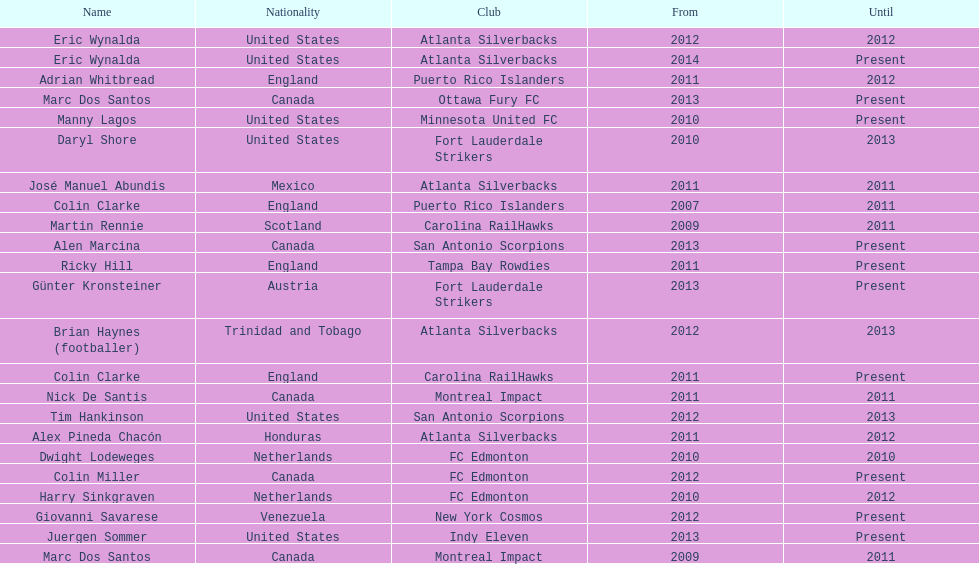How long did colin clarke coach the puerto rico islanders? 4 years. Write the full table. {'header': ['Name', 'Nationality', 'Club', 'From', 'Until'], 'rows': [['Eric Wynalda', 'United States', 'Atlanta Silverbacks', '2012', '2012'], ['Eric Wynalda', 'United States', 'Atlanta Silverbacks', '2014', 'Present'], ['Adrian Whitbread', 'England', 'Puerto Rico Islanders', '2011', '2012'], ['Marc Dos Santos', 'Canada', 'Ottawa Fury FC', '2013', 'Present'], ['Manny Lagos', 'United States', 'Minnesota United FC', '2010', 'Present'], ['Daryl Shore', 'United States', 'Fort Lauderdale Strikers', '2010', '2013'], ['José Manuel Abundis', 'Mexico', 'Atlanta Silverbacks', '2011', '2011'], ['Colin Clarke', 'England', 'Puerto Rico Islanders', '2007', '2011'], ['Martin Rennie', 'Scotland', 'Carolina RailHawks', '2009', '2011'], ['Alen Marcina', 'Canada', 'San Antonio Scorpions', '2013', 'Present'], ['Ricky Hill', 'England', 'Tampa Bay Rowdies', '2011', 'Present'], ['Günter Kronsteiner', 'Austria', 'Fort Lauderdale Strikers', '2013', 'Present'], ['Brian Haynes (footballer)', 'Trinidad and Tobago', 'Atlanta Silverbacks', '2012', '2013'], ['Colin Clarke', 'England', 'Carolina RailHawks', '2011', 'Present'], ['Nick De Santis', 'Canada', 'Montreal Impact', '2011', '2011'], ['Tim Hankinson', 'United States', 'San Antonio Scorpions', '2012', '2013'], ['Alex Pineda Chacón', 'Honduras', 'Atlanta Silverbacks', '2011', '2012'], ['Dwight Lodeweges', 'Netherlands', 'FC Edmonton', '2010', '2010'], ['Colin Miller', 'Canada', 'FC Edmonton', '2012', 'Present'], ['Harry Sinkgraven', 'Netherlands', 'FC Edmonton', '2010', '2012'], ['Giovanni Savarese', 'Venezuela', 'New York Cosmos', '2012', 'Present'], ['Juergen Sommer', 'United States', 'Indy Eleven', '2013', 'Present'], ['Marc Dos Santos', 'Canada', 'Montreal Impact', '2009', '2011']]} 